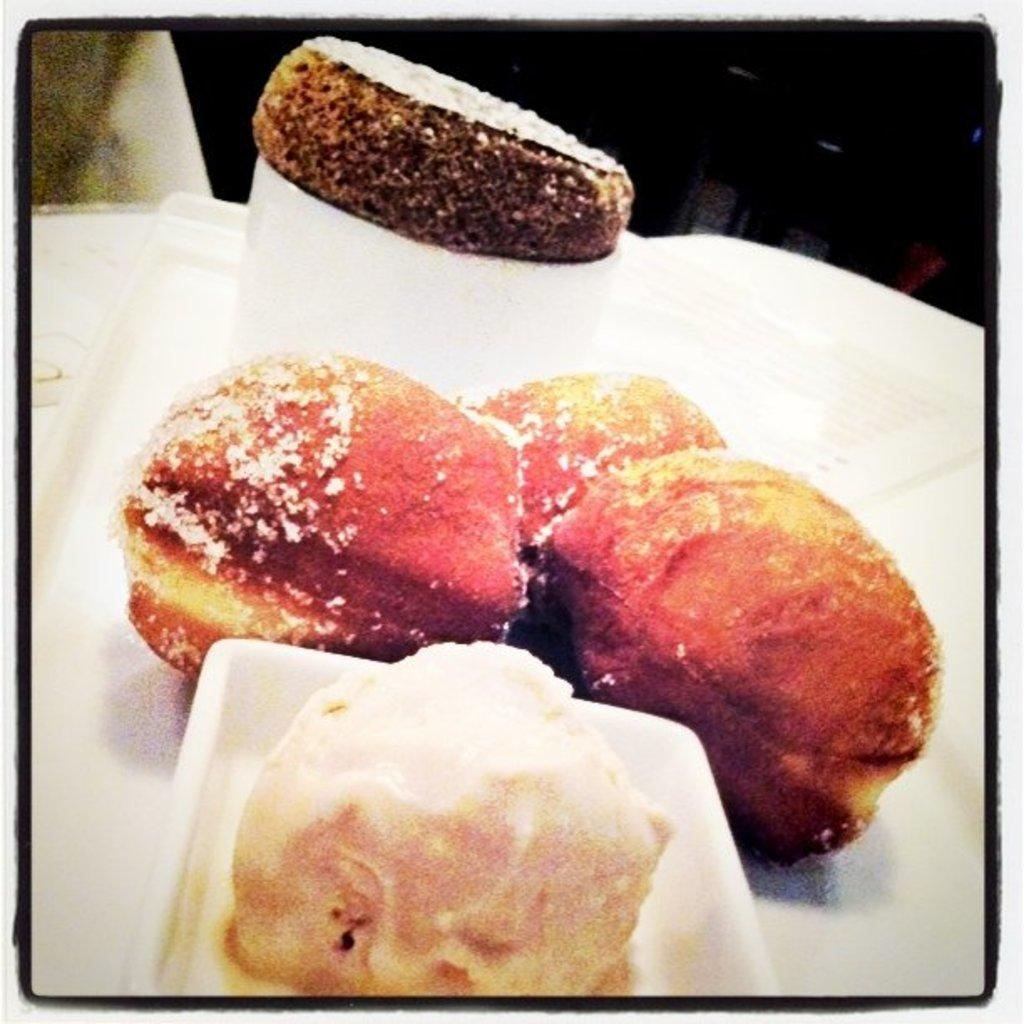What is on the plates in the image? There is food on plates in the image. What surface is the food placed on? There appears to be a table at the bottom of the image. Is there any furniture visible in the image? There might be a chair at the back of the image. What type of collar is visible on the food in the image? There is no collar present on the food in the image. How many degrees can be seen in the image? There are no degrees visible in the image. 